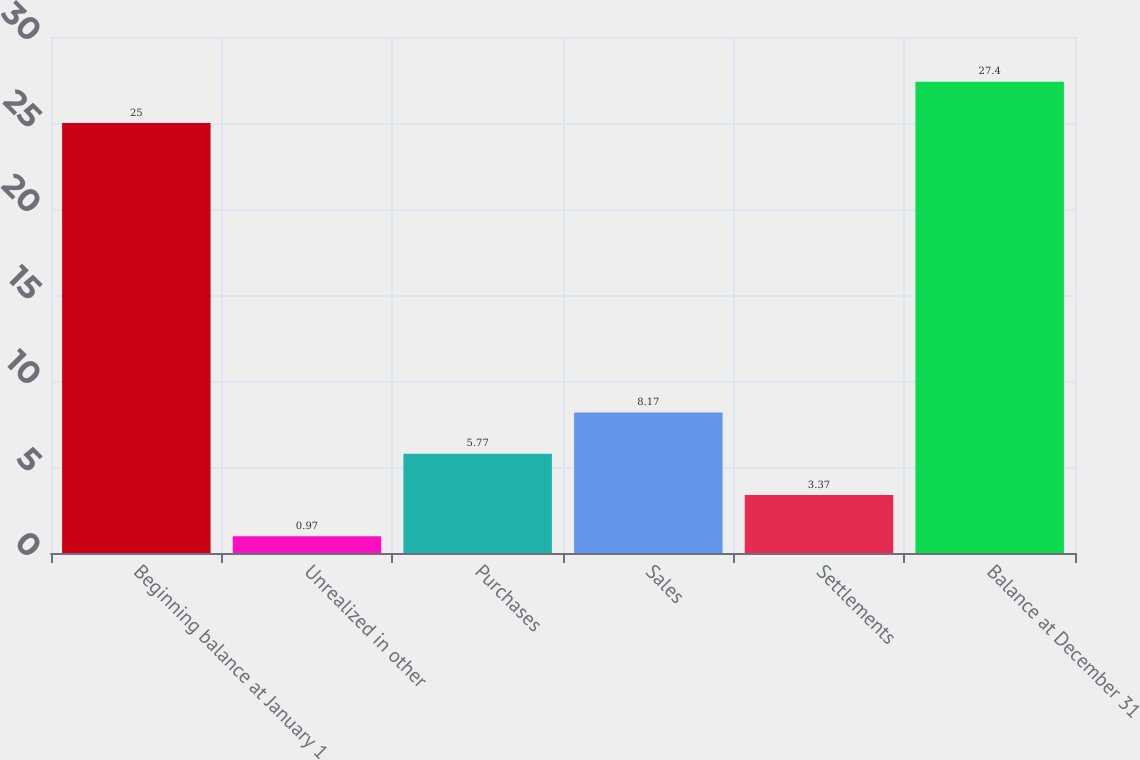Convert chart. <chart><loc_0><loc_0><loc_500><loc_500><bar_chart><fcel>Beginning balance at January 1<fcel>Unrealized in other<fcel>Purchases<fcel>Sales<fcel>Settlements<fcel>Balance at December 31<nl><fcel>25<fcel>0.97<fcel>5.77<fcel>8.17<fcel>3.37<fcel>27.4<nl></chart> 